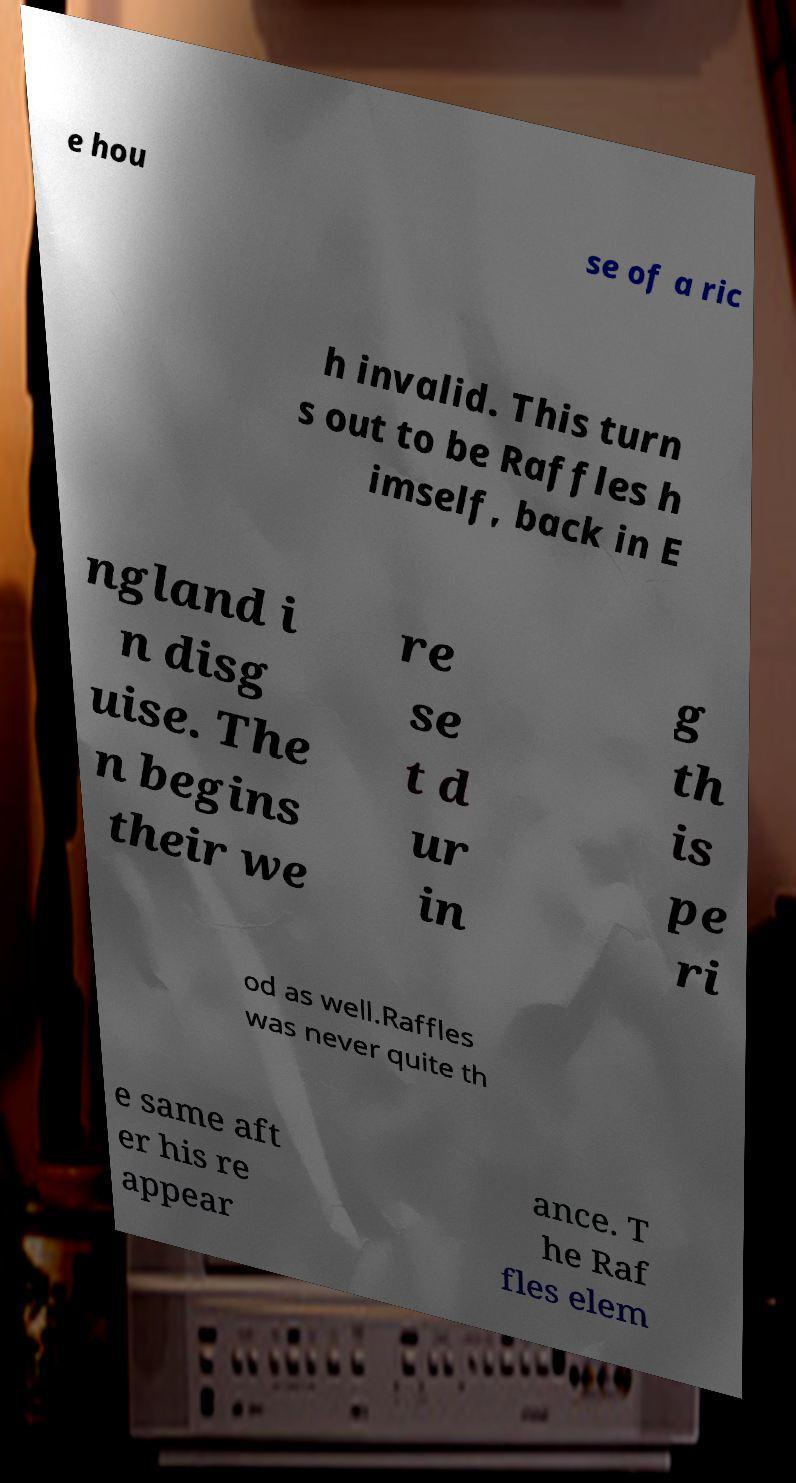Can you accurately transcribe the text from the provided image for me? e hou se of a ric h invalid. This turn s out to be Raffles h imself, back in E ngland i n disg uise. The n begins their we re se t d ur in g th is pe ri od as well.Raffles was never quite th e same aft er his re appear ance. T he Raf fles elem 